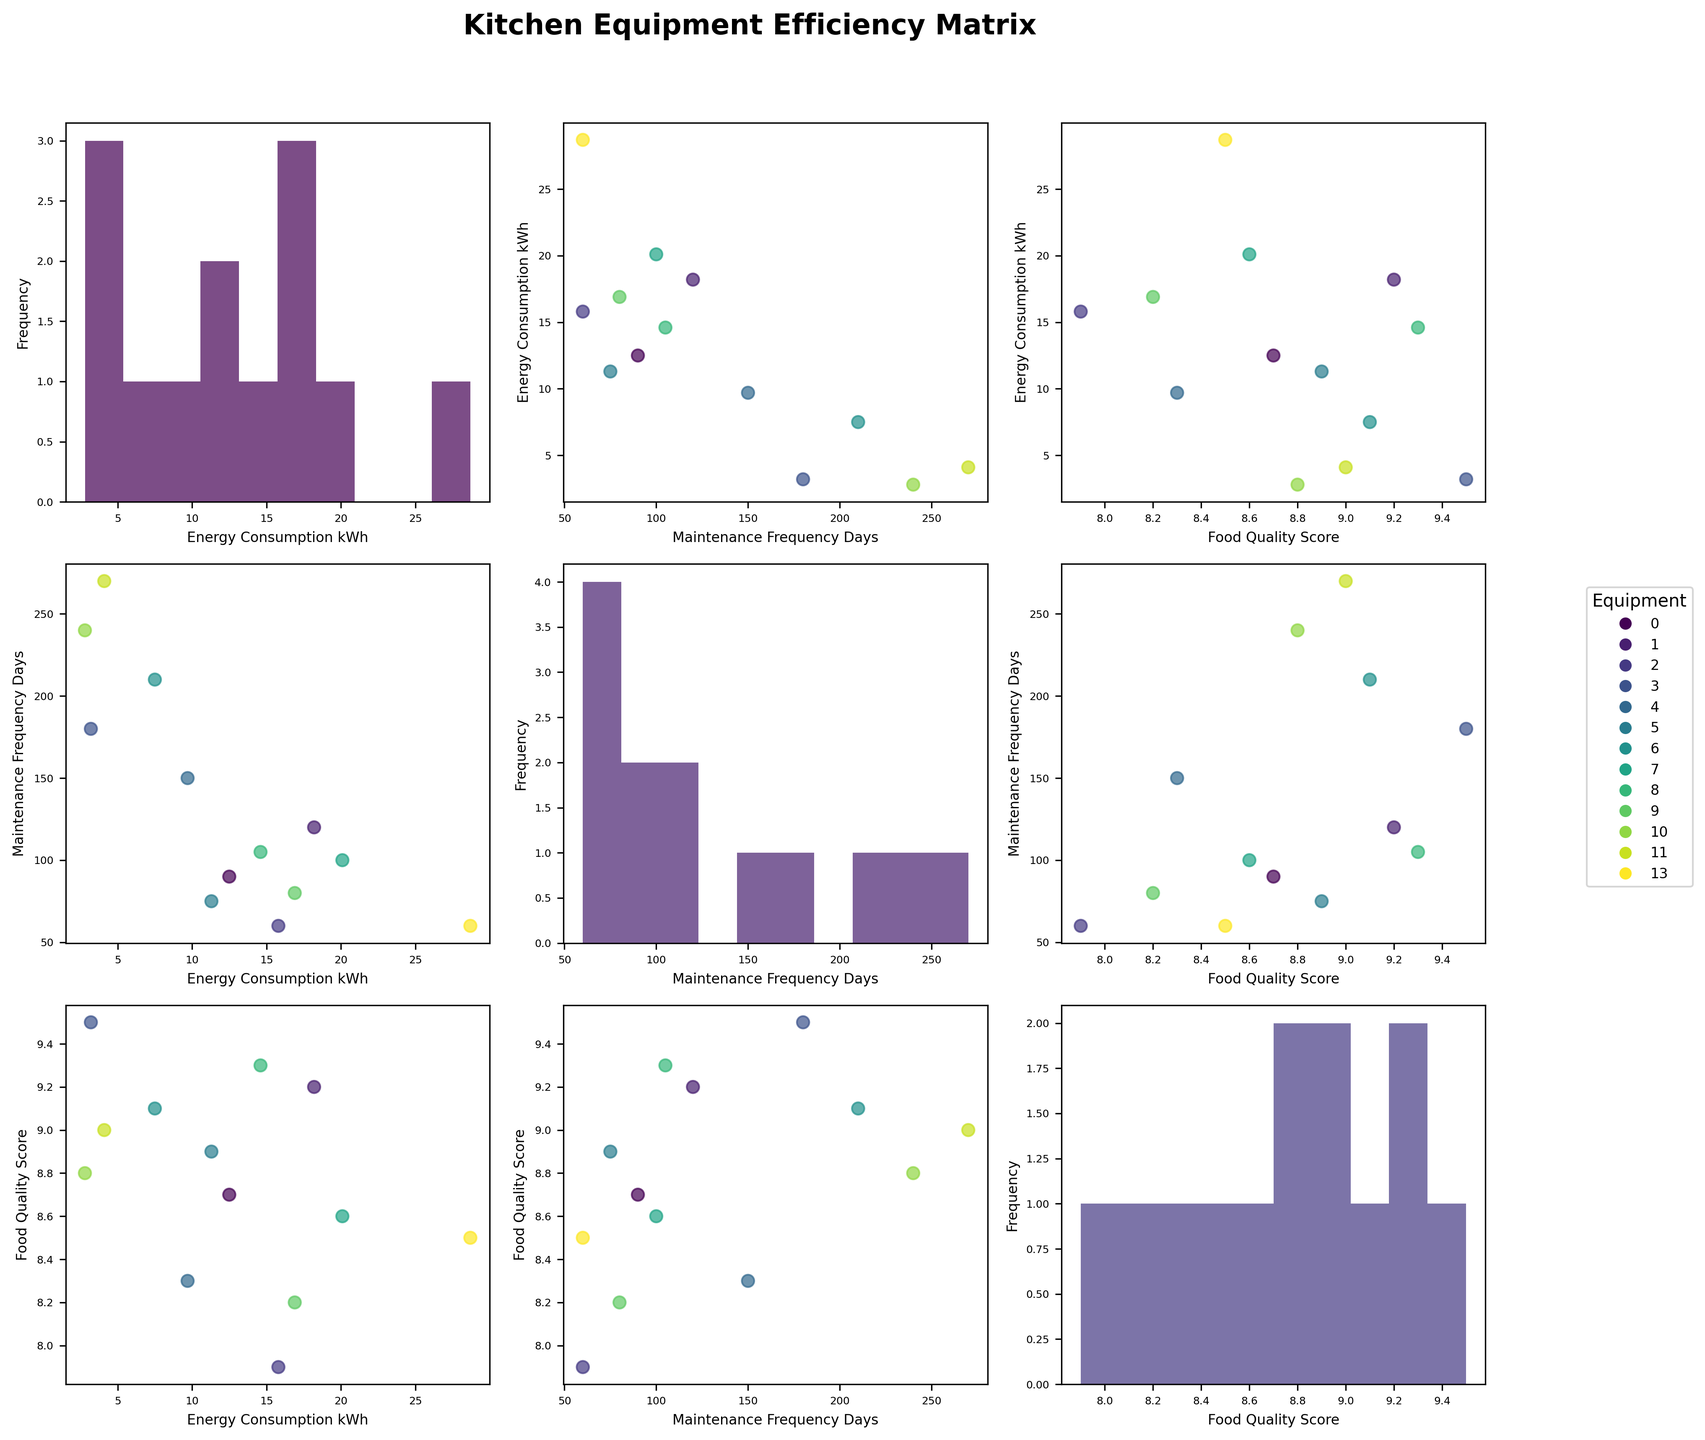What is the overall title of the figure? The title is usually placed at the top center of the figure. Here it states: "Kitchen Equipment Efficiency Matrix".
Answer: Kitchen Equipment Efficiency Matrix How many subplots are there in the matrix? Each intersection of the variables creates a subplot. The matrix is 3x3, resulting in 9 subplots.
Answer: 9 What color scheme is used in the figure? Looking at the scatterplot points and histogram bars, one can recognize the use of a gradient color scheme, commonly known as 'viridis'.
Answer: viridis Which two equipment types have the highest and the lowest energy consumption? The histogram for Energy_Consumption_kWh reveals that Walk-in Refrigerator has the highest energy consumption, and Food Processor has the lowest.
Answer: Walk-in Refrigerator and Food Processor What is the relationship between Energy Consumption and Maintenance Frequency? In the scatterplot between Energy_Consumption_kWh and Maintenance_Frequency_Days, most points do not show a clear linear relationship, indicating no strong correlation.
Answer: No strong correlation What equipment has both high Maintenance Frequency and high Food Quality Score? Look at the scatterplot between Maintenance_Frequency_Days and Food_Quality_Score. The Sous Vide Machine has a high value for both axes.
Answer: Sous Vide Machine Which equipment tends to require more frequent maintenance, high or low energy consumers? Observing the scatterplot of Energy_Consumption_kWh vs Maintenance_Frequency_Days, it appears that lower energy consumers have higher maintenance frequencies, e.g., Food Processor, Rice Cooker, Induction Cooktop.
Answer: Lower energy consumers What's the average Food Quality Score for all equipment? Compute the mean of the Food_Quality_Score from the data. Excluding N/A, sum the scores: (8.7 + 9.2 + 7.9 + 9.5 + 8.3 + 8.9 + 9.1 + 8.6 + 9.3 + 8.2 + 8.8 + 9.0) / 12 = 105.5 / 12.
Answer: 8.8 Comparing the salamander grill and the griddle, which one has a higher food quality score? From the data plotted against Food_Quality_Score, Salamander Grill has a score of 8.3 while Griddle has 8.2.
Answer: Salamander Grill Does higher Food Quality Score imply less maintenance frequency? In the scatterplot comparing Food_Quality_Score and Maintenance_Frequency_Days, there is no clear inverse trend visible indicating less maintenance with higher Food Quality Score.
Answer: No 